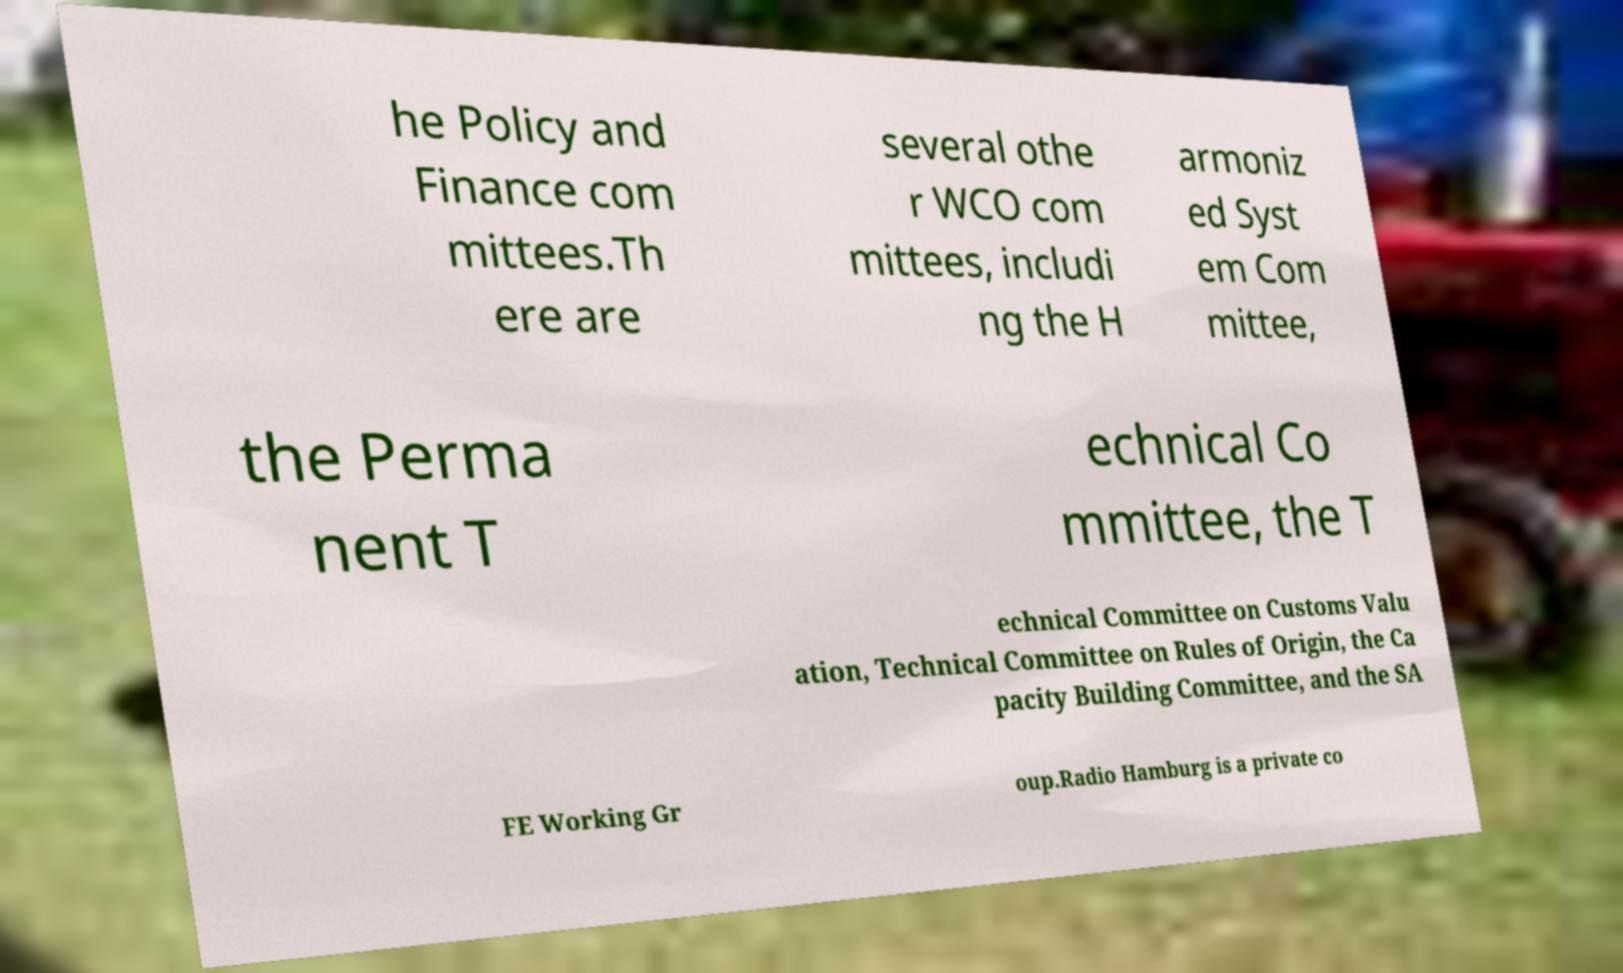Could you assist in decoding the text presented in this image and type it out clearly? he Policy and Finance com mittees.Th ere are several othe r WCO com mittees, includi ng the H armoniz ed Syst em Com mittee, the Perma nent T echnical Co mmittee, the T echnical Committee on Customs Valu ation, Technical Committee on Rules of Origin, the Ca pacity Building Committee, and the SA FE Working Gr oup.Radio Hamburg is a private co 